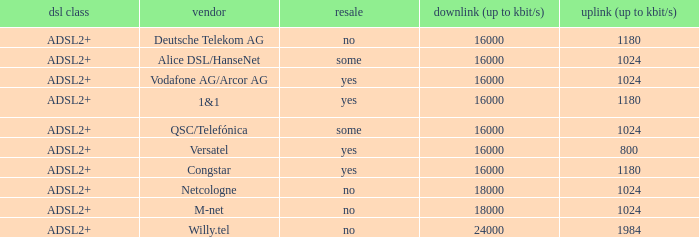What are all the dsl type offered by the M-Net telecom company? ADSL2+. 